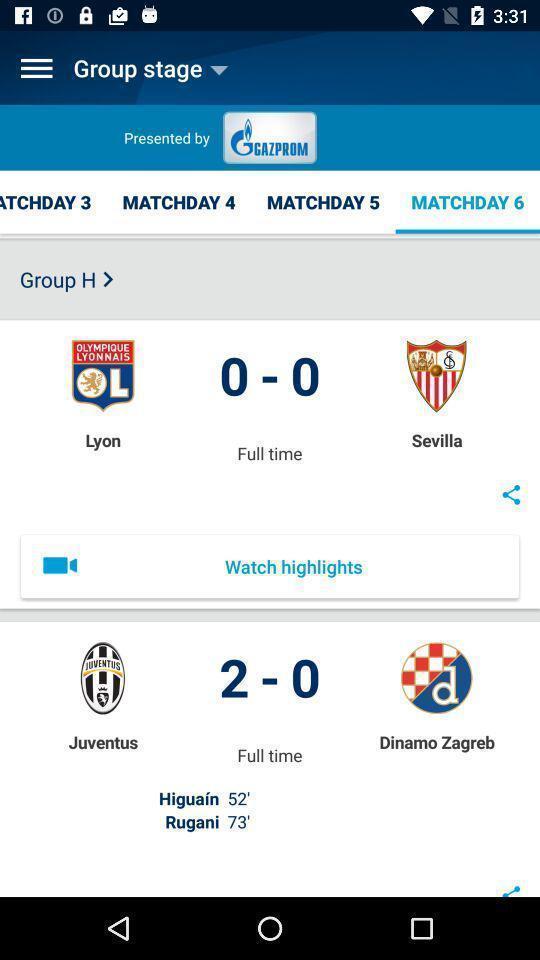Tell me what you see in this picture. Page shows the match score details on sports app. 